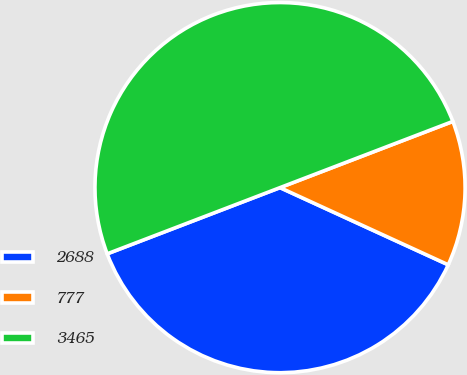<chart> <loc_0><loc_0><loc_500><loc_500><pie_chart><fcel>2688<fcel>777<fcel>3465<nl><fcel>37.33%<fcel>12.67%<fcel>50.0%<nl></chart> 